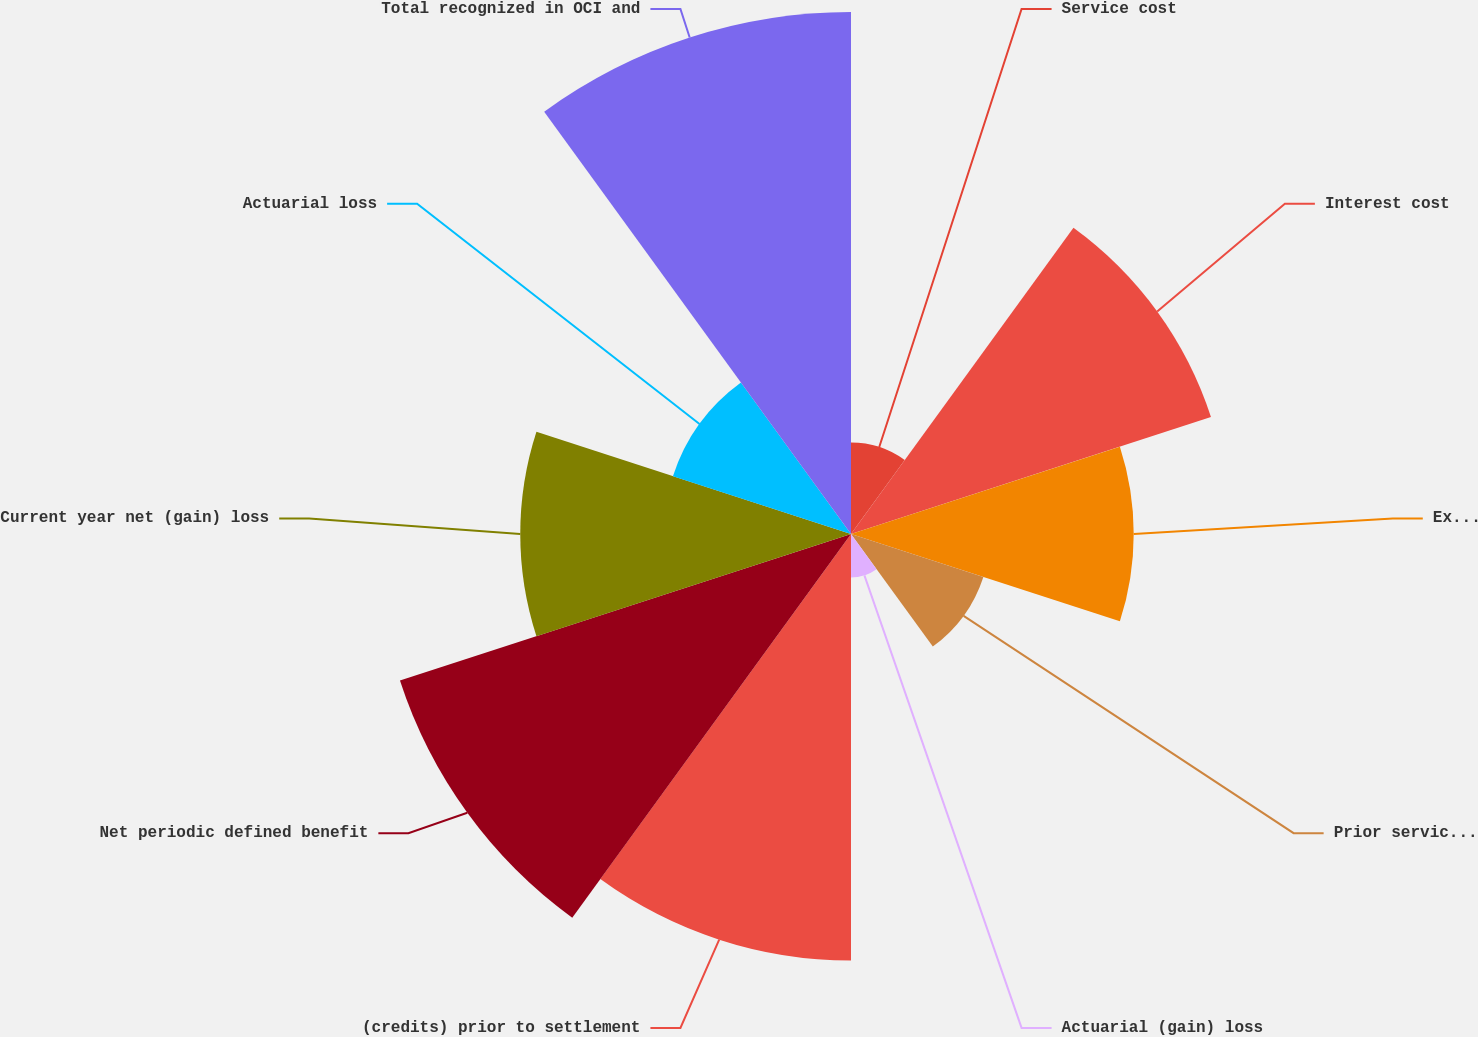<chart> <loc_0><loc_0><loc_500><loc_500><pie_chart><fcel>Service cost<fcel>Interest cost<fcel>Expected return on plan assets<fcel>Prior service cost<fcel>Actuarial (gain) loss<fcel>(credits) prior to settlement<fcel>Net periodic defined benefit<fcel>Current year net (gain) loss<fcel>Actuarial loss<fcel>Total recognized in OCI and<nl><fcel>3.18%<fcel>13.16%<fcel>9.83%<fcel>4.84%<fcel>1.51%<fcel>14.83%<fcel>16.49%<fcel>11.5%<fcel>6.51%<fcel>18.15%<nl></chart> 